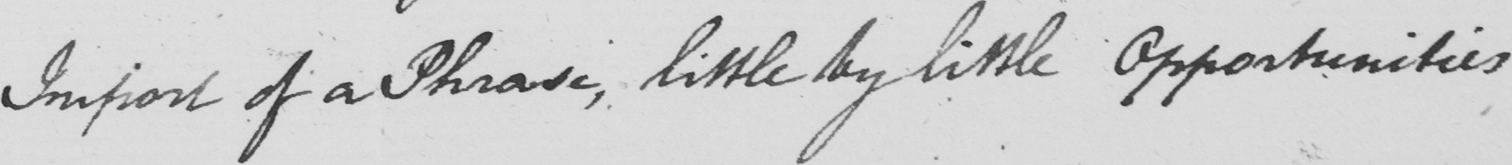Can you read and transcribe this handwriting? Import of a Phrase , little by little Opportunities 